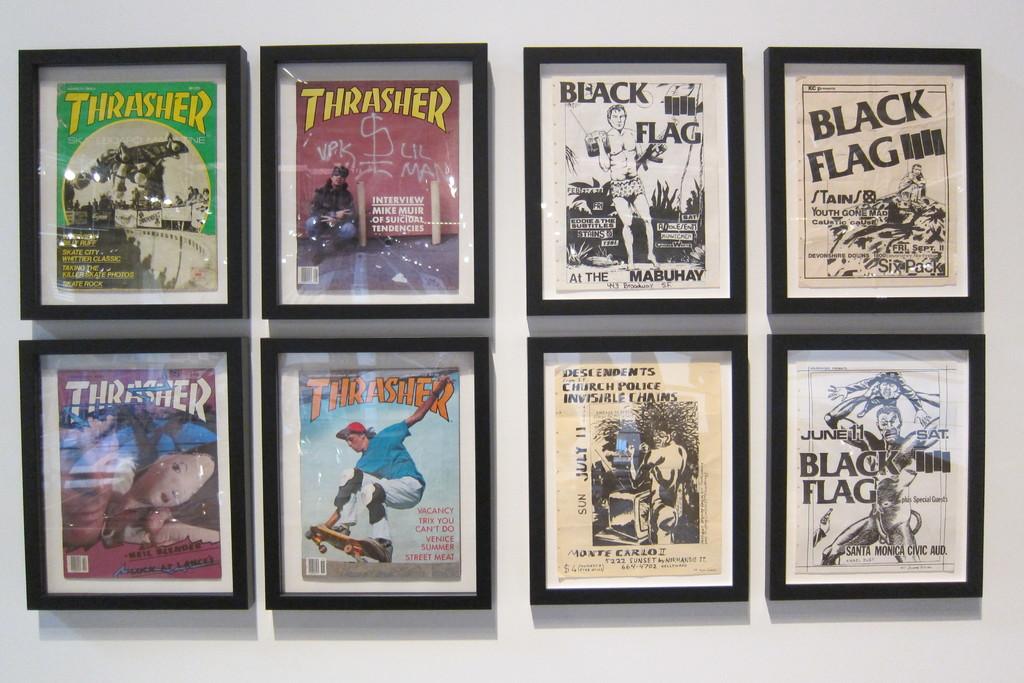Is there a black flag poster up there?
Provide a short and direct response. Yes. What is the title of the top left cover?
Ensure brevity in your answer.  Thrasher. 